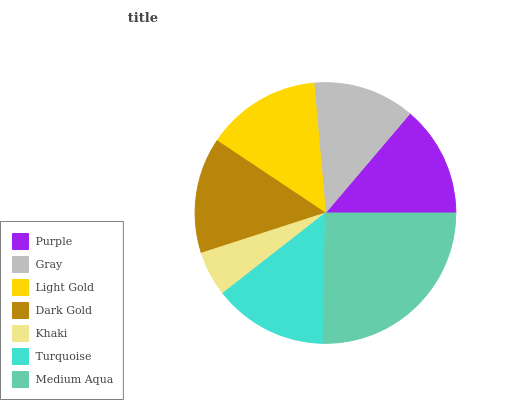Is Khaki the minimum?
Answer yes or no. Yes. Is Medium Aqua the maximum?
Answer yes or no. Yes. Is Gray the minimum?
Answer yes or no. No. Is Gray the maximum?
Answer yes or no. No. Is Purple greater than Gray?
Answer yes or no. Yes. Is Gray less than Purple?
Answer yes or no. Yes. Is Gray greater than Purple?
Answer yes or no. No. Is Purple less than Gray?
Answer yes or no. No. Is Turquoise the high median?
Answer yes or no. Yes. Is Turquoise the low median?
Answer yes or no. Yes. Is Medium Aqua the high median?
Answer yes or no. No. Is Khaki the low median?
Answer yes or no. No. 